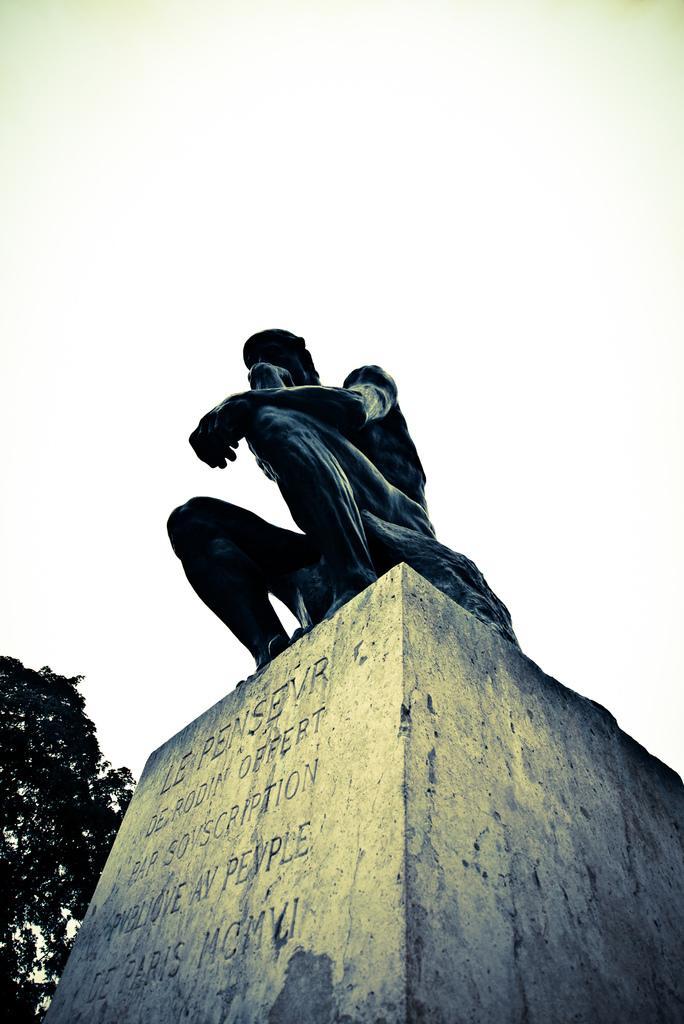Describe this image in one or two sentences. This image consists of a statue in the middle. There is a tree on the left side. There is sky at the top. 